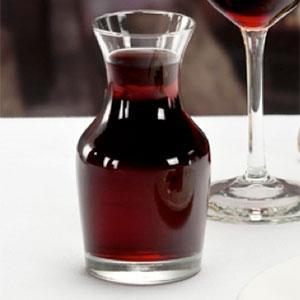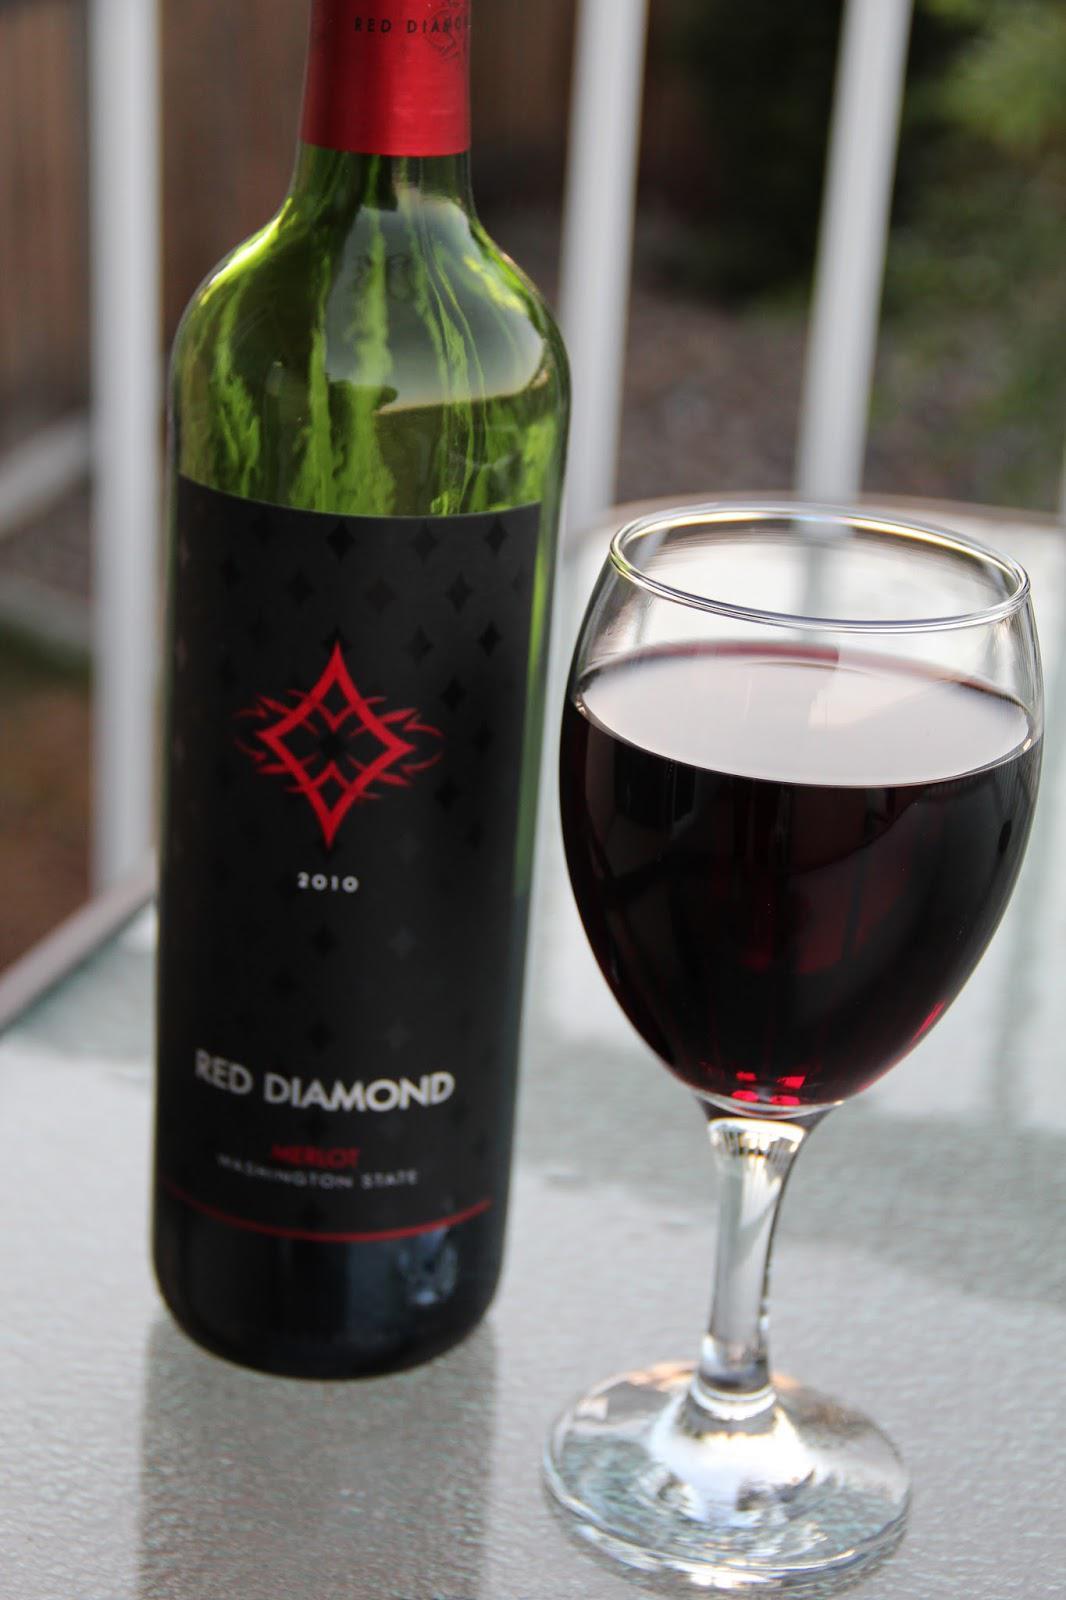The first image is the image on the left, the second image is the image on the right. For the images displayed, is the sentence "there is a bottle of wine in the iamge on the left" factually correct? Answer yes or no. No. The first image is the image on the left, the second image is the image on the right. For the images shown, is this caption "An image shows only several partly filled wine glasses." true? Answer yes or no. No. 